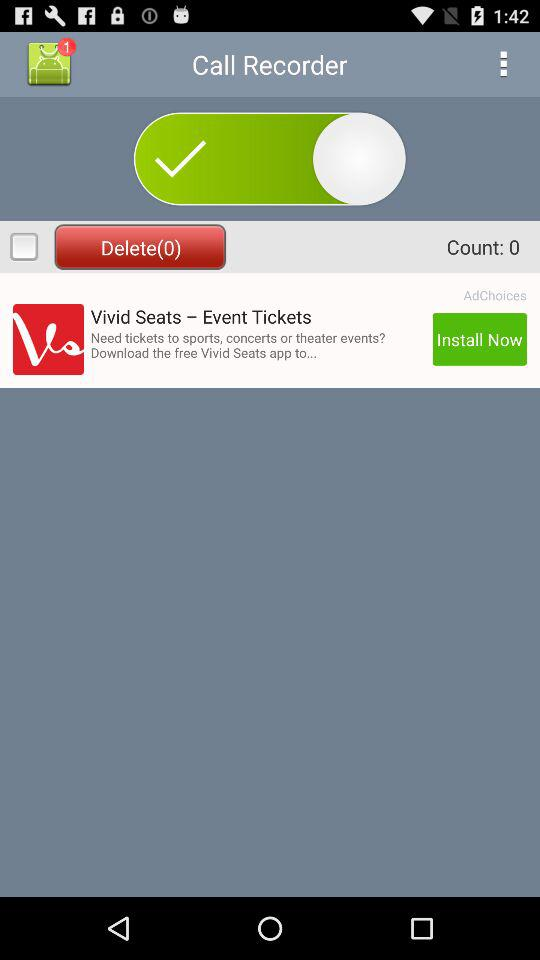What is the status of "Delete"? The status of "Delete" is "off". 